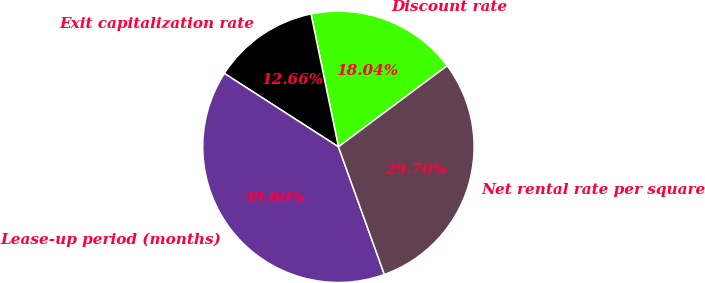Convert chart to OTSL. <chart><loc_0><loc_0><loc_500><loc_500><pie_chart><fcel>Discount rate<fcel>Exit capitalization rate<fcel>Lease-up period (months)<fcel>Net rental rate per square<nl><fcel>18.04%<fcel>12.66%<fcel>39.6%<fcel>29.7%<nl></chart> 